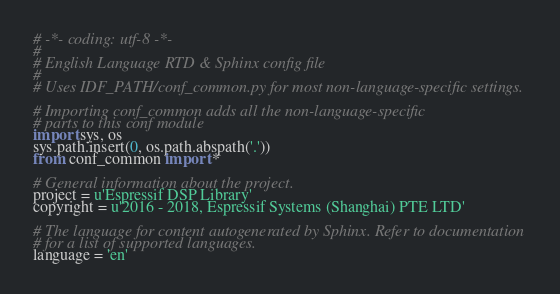<code> <loc_0><loc_0><loc_500><loc_500><_Python_># -*- coding: utf-8 -*-
#
# English Language RTD & Sphinx config file
#
# Uses IDF_PATH/conf_common.py for most non-language-specific settings.

# Importing conf_common adds all the non-language-specific
# parts to this conf module
import sys, os
sys.path.insert(0, os.path.abspath('.'))
from conf_common import *

# General information about the project.
project = u'Espressif DSP Library'
copyright = u'2016 - 2018, Espressif Systems (Shanghai) PTE LTD'

# The language for content autogenerated by Sphinx. Refer to documentation
# for a list of supported languages.
language = 'en'
</code> 